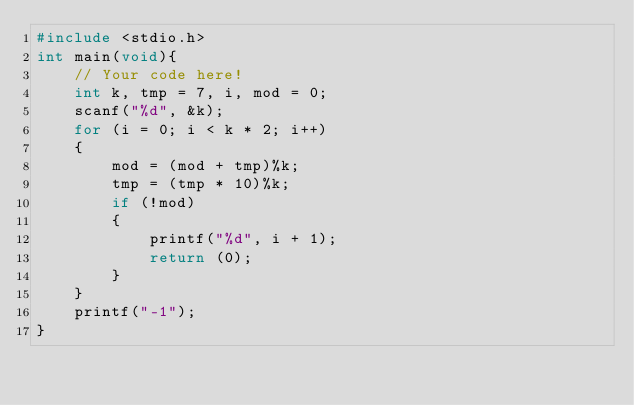Convert code to text. <code><loc_0><loc_0><loc_500><loc_500><_C_>#include <stdio.h>
int main(void){
    // Your code here!
    int k, tmp = 7, i, mod = 0;
    scanf("%d", &k);
    for (i = 0; i < k * 2; i++)
    {
        mod = (mod + tmp)%k;
        tmp = (tmp * 10)%k;
        if (!mod)
        {
            printf("%d", i + 1);
            return (0);
        }
    }
    printf("-1");
}
</code> 